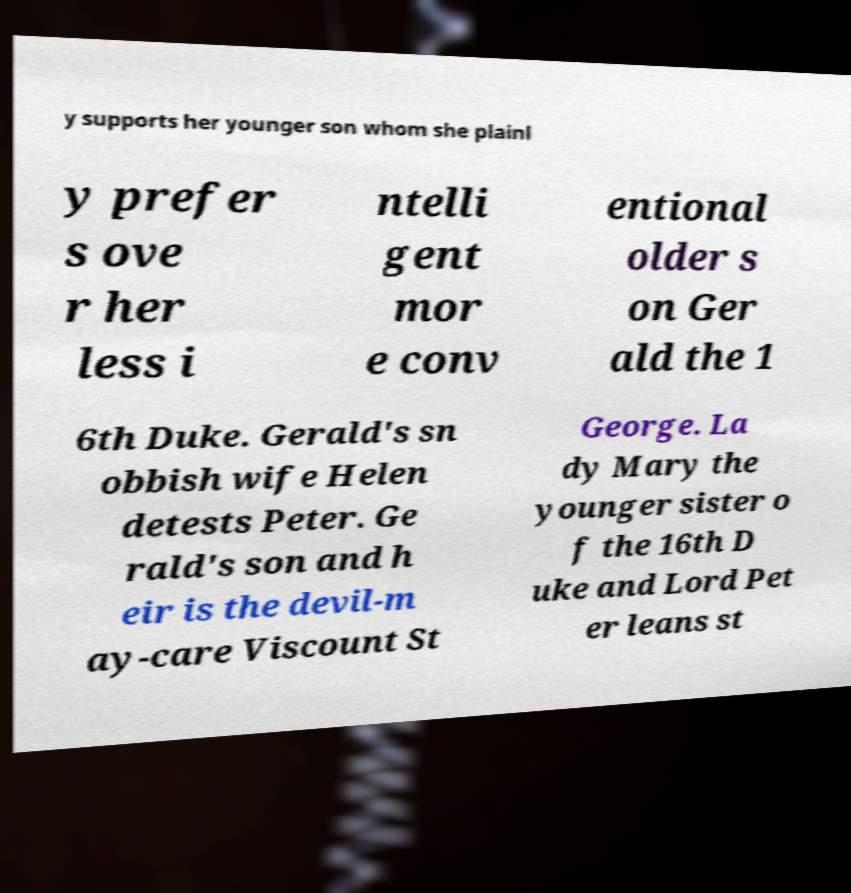There's text embedded in this image that I need extracted. Can you transcribe it verbatim? y supports her younger son whom she plainl y prefer s ove r her less i ntelli gent mor e conv entional older s on Ger ald the 1 6th Duke. Gerald's sn obbish wife Helen detests Peter. Ge rald's son and h eir is the devil-m ay-care Viscount St George. La dy Mary the younger sister o f the 16th D uke and Lord Pet er leans st 